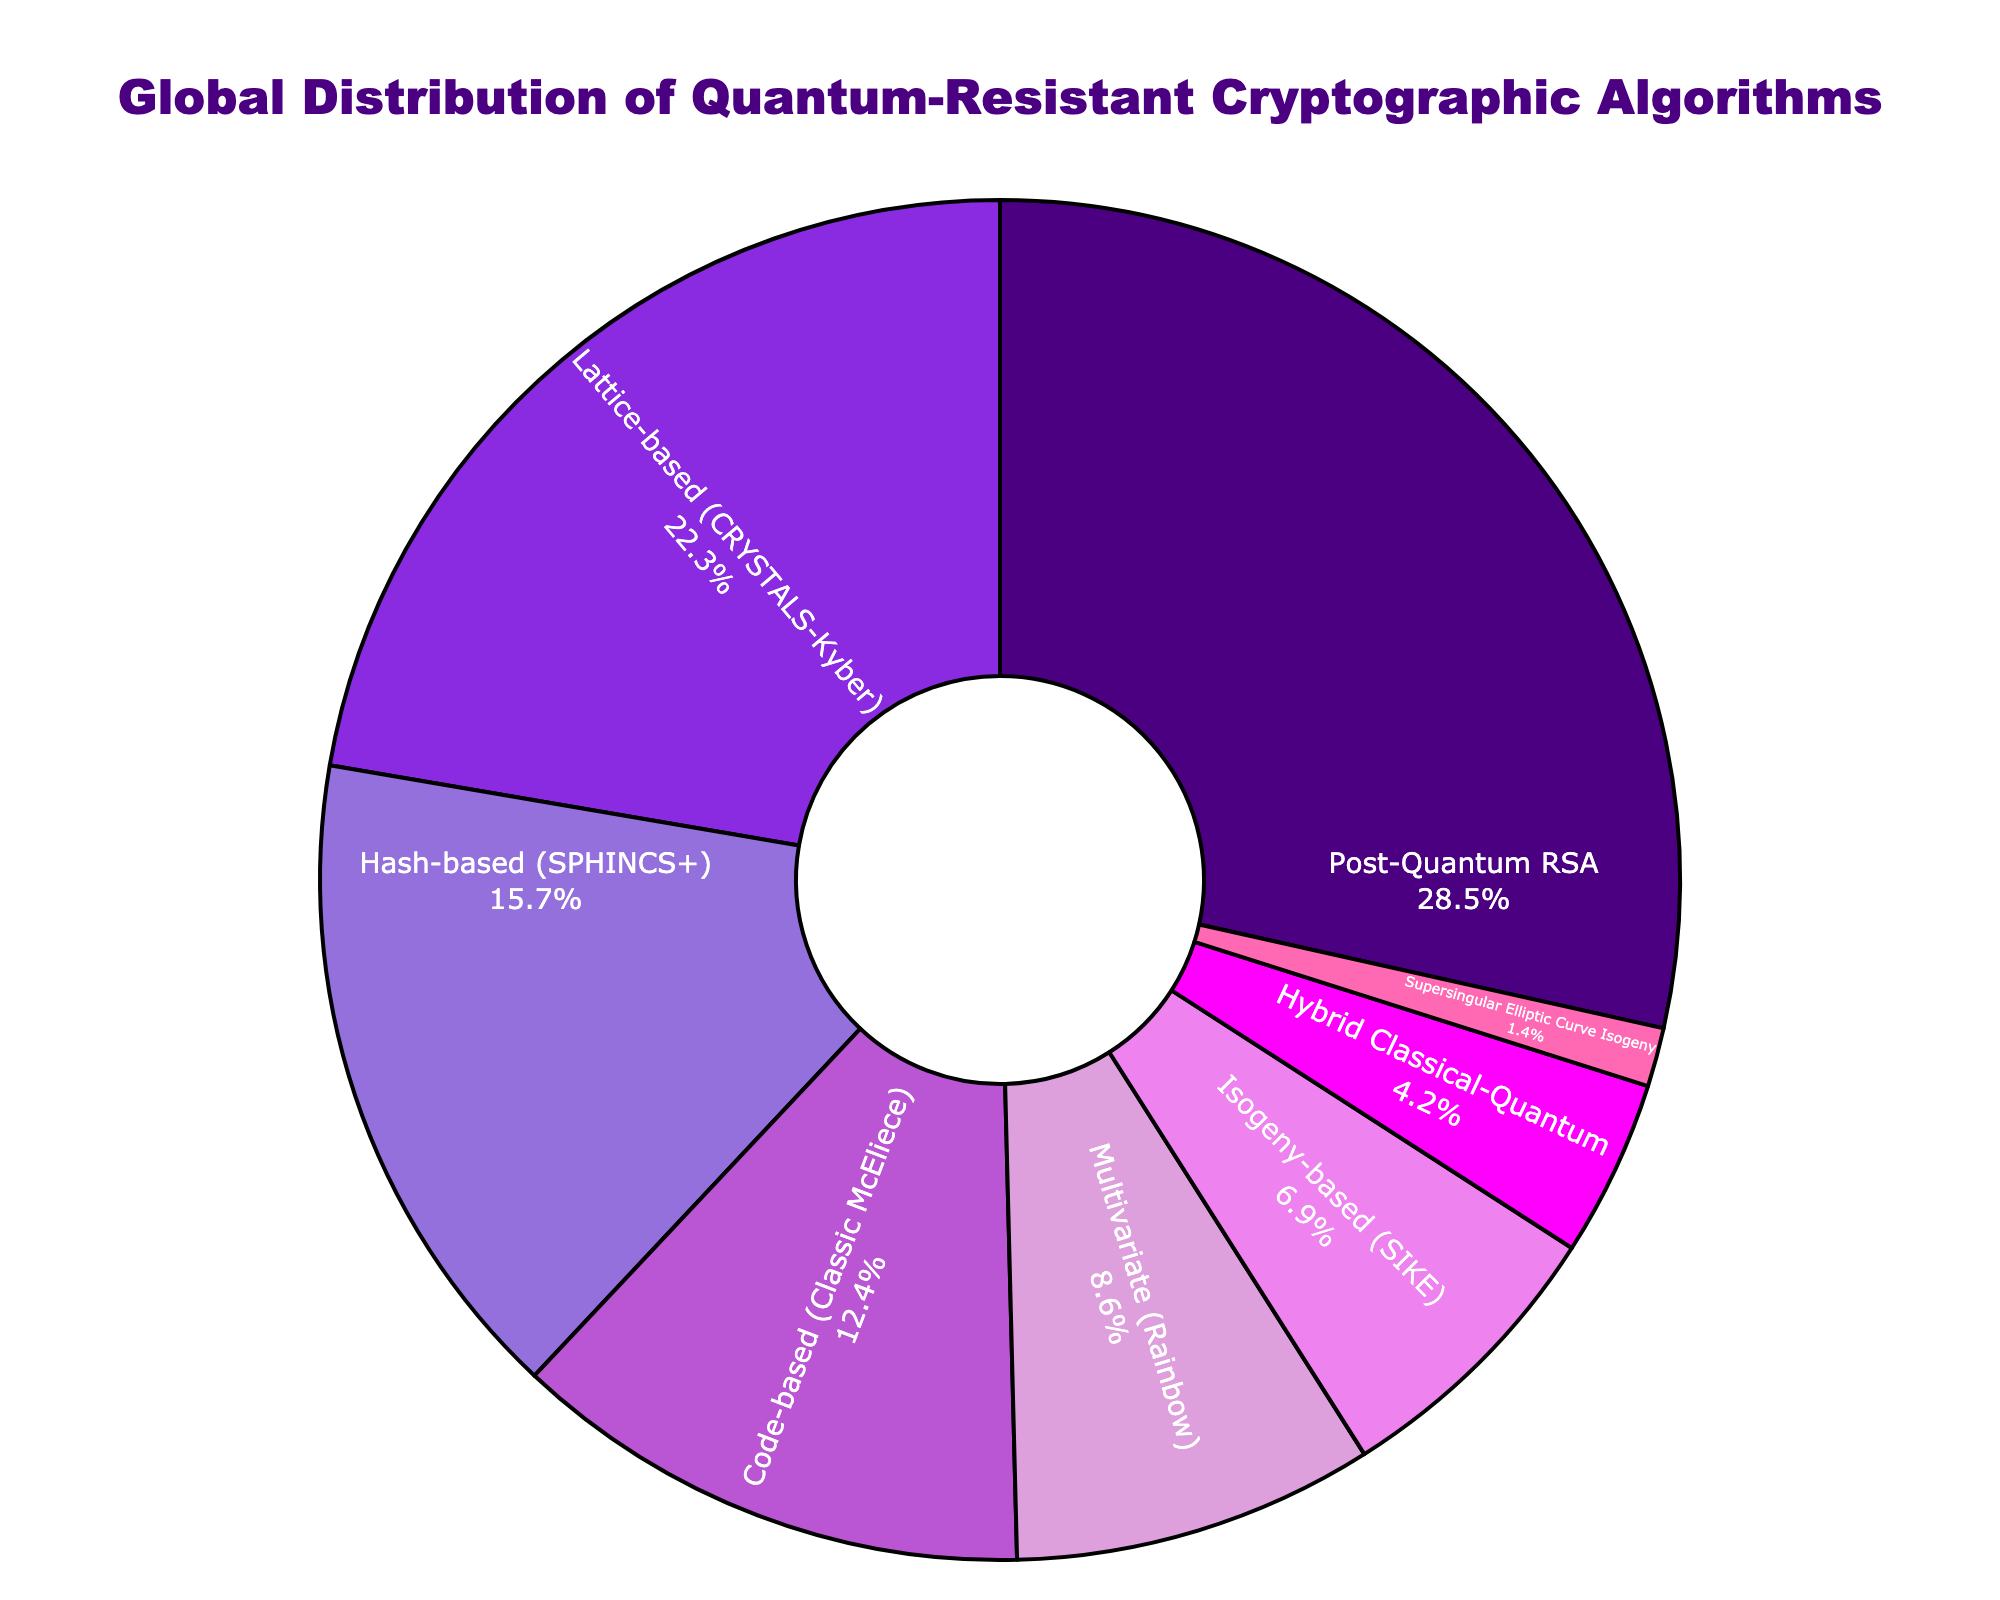What percentage of the global distribution is represented by the Lattice-based (CRYSTALS-Kyber) algorithm? The Lattice-based (CRYSTALS-Kyber) algorithm's slice in the pie chart indicates its percentage of the global distribution. Looking at the chart, the corresponding percentage is 22.3%.
Answer: 22.3% Which algorithm has the smallest percentage in the global distribution? The algorithm with the smallest slice in the pie chart represents the smallest percentage. The Supersingular Elliptic Curve Isogeny algorithm has the smallest slice, indicating a percentage of 1.4%.
Answer: Supersingular Elliptic Curve Isogeny What is the difference in percentage between the Post-Quantum RSA and Isogeny-based (SIKE) algorithms? To find the difference, identify the percentages for both algorithms from the chart and subtract the smaller percentage from the larger one: 28.5% (Post-Quantum RSA) - 6.9% (Isogeny-based (SIKE)) = 21.6%.
Answer: 21.6% Which algorithm groups have a combined percentage greater than 50%? Sum the percentages of the algorithms from the largest down until the combined percentage exceeds 50%:
- Post-Quantum RSA: 28.5%
- Lattice-based (CRYSTALS-Kyber): 22.3%
28.5% + 22.3% = 50.8%. So, the Post-Quantum RSA and Lattice-based (CRYSTALS-Kyber) together exceed 50%.
Answer: Post-Quantum RSA and Lattice-based (CRYSTALS-Kyber) What is the total percentage represented by the Hybrid Classical-Quantum, Isogeny-based (SIKE), and Supersingular Elliptic Curve Isogeny algorithms combined? Add the percentages of the three algorithms: 4.2% (Hybrid Classical-Quantum) + 6.9% (Isogeny-based (SIKE)) + 1.4% (Supersingular Elliptic Curve Isogeny) = 12.5%.
Answer: 12.5% Between the Hash-based (SPHINCS+) and Code-based (Classic McEliece) algorithms, which one has a higher percentage and by how much? The Hash-based (SPHINCS+) algorithm is 15.7% and the Code-based (Classic McEliece) is 12.4%. The difference is 15.7% - 12.4% = 3.3%.
Answer: Hash-based (SPHINCS+) by 3.3% Identify the algorithms represented by the two largest slices in the pie chart. The two largest slices in the pie chart are for Post-Quantum RSA (28.5%) and Lattice-based (CRYSTALS-Kyber) (22.3%).
Answer: Post-Quantum RSA and Lattice-based (CRYSTALS-Kyber) What color is associated with the Multivariate (Rainbow) algorithm in the pie chart? The slice representing the Multivariate (Rainbow) algorithm is visually distinct, and it is associated with a specific color in the pie chart, which is violet.
Answer: Violet 